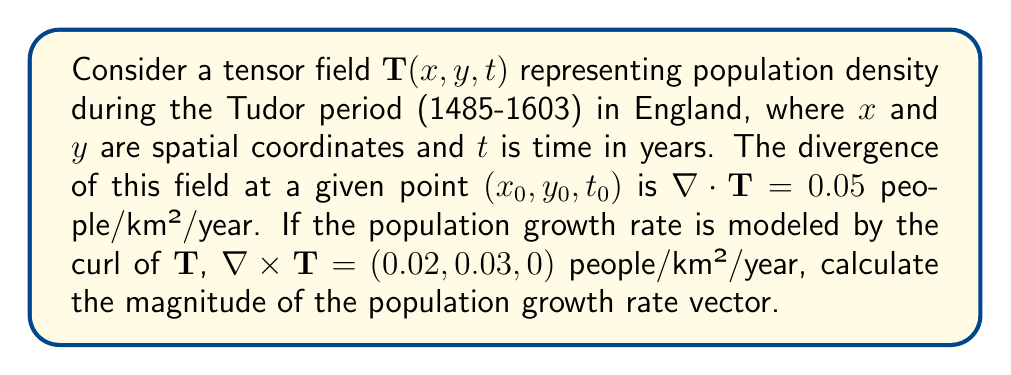Help me with this question. To solve this problem, we'll follow these steps:

1) The curl of the tensor field $\mathbf{T}$ is given as:

   $\nabla \times \mathbf{T} = (0.02, 0.03, 0)$ people/km²/year

2) The magnitude of a vector $\mathbf{v} = (a, b, c)$ is calculated using the formula:

   $|\mathbf{v}| = \sqrt{a^2 + b^2 + c^2}$

3) In this case, we have:
   
   $a = 0.02$
   $b = 0.03$
   $c = 0$

4) Substituting these values into the magnitude formula:

   $|\nabla \times \mathbf{T}| = \sqrt{(0.02)^2 + (0.03)^2 + 0^2}$

5) Simplifying:

   $|\nabla \times \mathbf{T}| = \sqrt{0.0004 + 0.0009 + 0}$
   
   $|\nabla \times \mathbf{T}| = \sqrt{0.0013}$

6) Calculating the square root:

   $|\nabla \times \mathbf{T}| \approx 0.0360555127546399$ people/km²/year

7) Rounding to four decimal places for a reasonable level of precision:

   $|\nabla \times \mathbf{T}| \approx 0.0361$ people/km²/year

This represents the magnitude of the population growth rate vector during the Tudor period, according to the given model.
Answer: $0.0361$ people/km²/year 